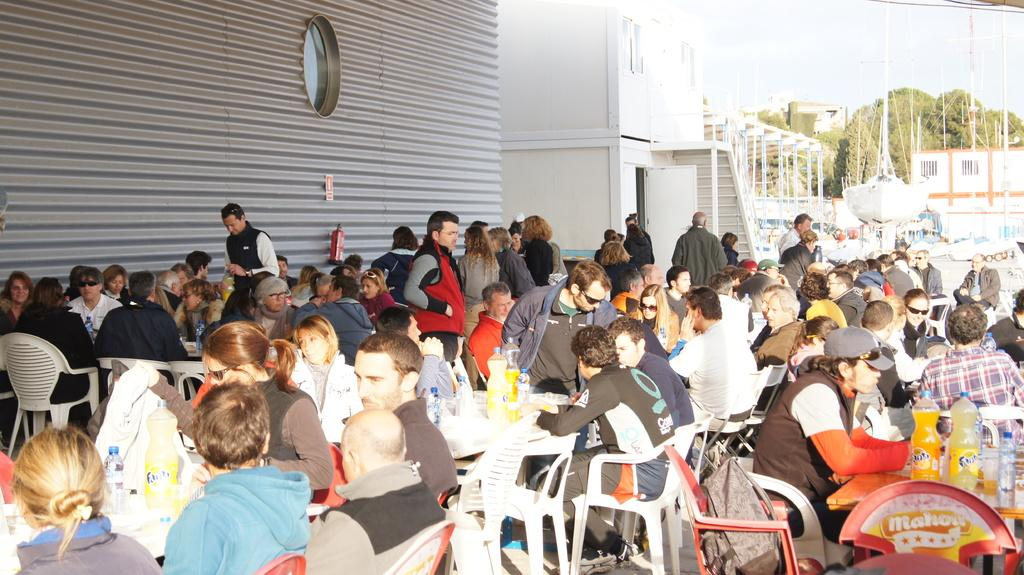How many people are in the image? There is a group of people in the image. What are the people doing in the image? The people are sitting on a table and having their meal. What can be seen in the background of the image? There are buildings and trees in the background of the image. What type of wool is being used to knit a scarf in the image? There is no wool or knitting activity present in the image. Can you describe the sidewalk in the image? There is no sidewalk present in the image. 